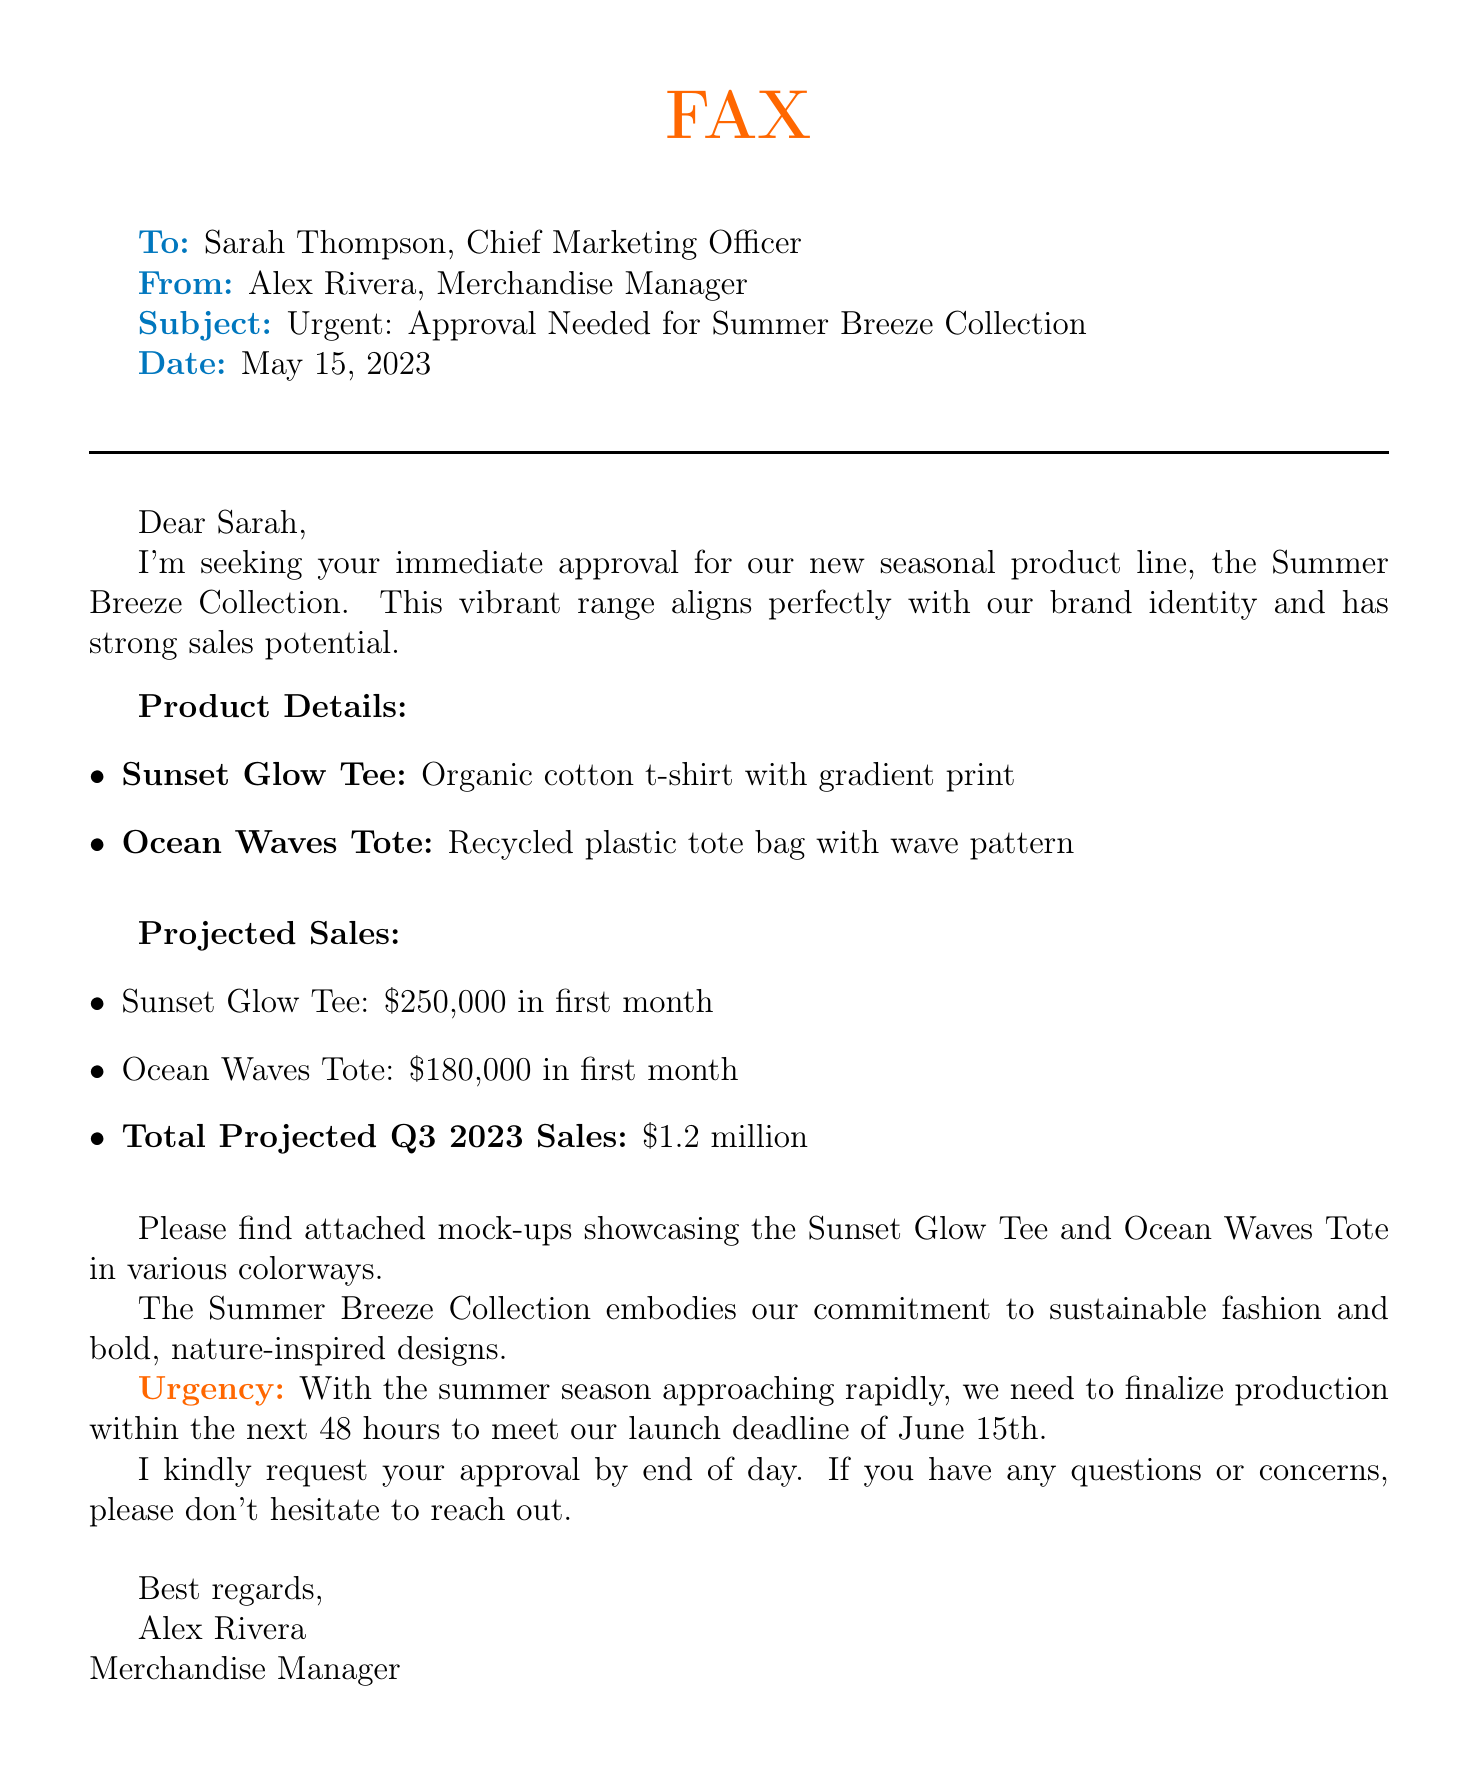What is the name of the new product line? The document mentions the new product line as the Summer Breeze Collection.
Answer: Summer Breeze Collection Who is the fax addressed to? The fax is addressed to Sarah Thompson, who is the Chief Marketing Officer.
Answer: Sarah Thompson What are the two products included in the collection? The two products listed are the Sunset Glow Tee and the Ocean Waves Tote.
Answer: Sunset Glow Tee, Ocean Waves Tote What is the total projected sales for Q3 2023? The total projected sales listed in the document for Q3 2023 is $1.2 million.
Answer: $1.2 million What is the urgency for approval stated in the document? The document states the urgency is related to finalizing production within the next 48 hours to meet a launch deadline.
Answer: 48 hours When is the launch deadline for the product line? The launch deadline mentioned in the fax is June 15th.
Answer: June 15th 